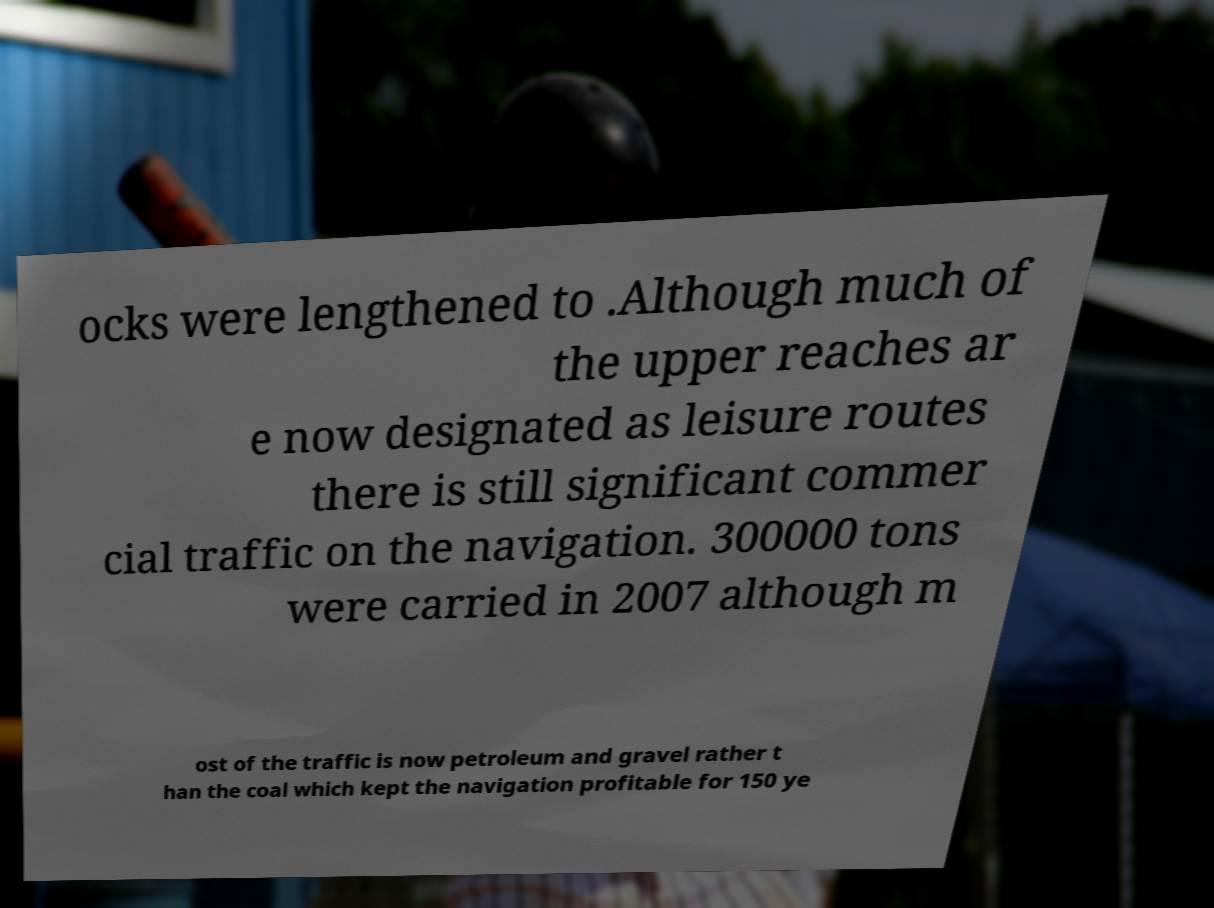Could you assist in decoding the text presented in this image and type it out clearly? ocks were lengthened to .Although much of the upper reaches ar e now designated as leisure routes there is still significant commer cial traffic on the navigation. 300000 tons were carried in 2007 although m ost of the traffic is now petroleum and gravel rather t han the coal which kept the navigation profitable for 150 ye 